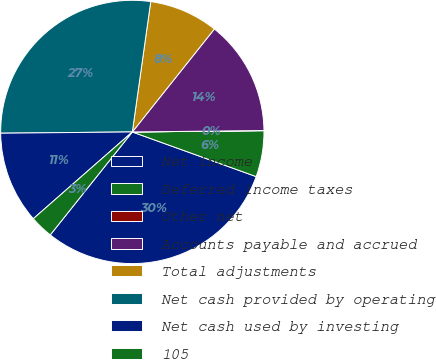Convert chart to OTSL. <chart><loc_0><loc_0><loc_500><loc_500><pie_chart><fcel>Net income<fcel>Deferred income taxes<fcel>Other net<fcel>Accounts payable and accrued<fcel>Total adjustments<fcel>Net cash provided by operating<fcel>Net cash used by investing<fcel>105<nl><fcel>30.21%<fcel>5.66%<fcel>0.02%<fcel>14.12%<fcel>8.48%<fcel>27.39%<fcel>11.3%<fcel>2.84%<nl></chart> 